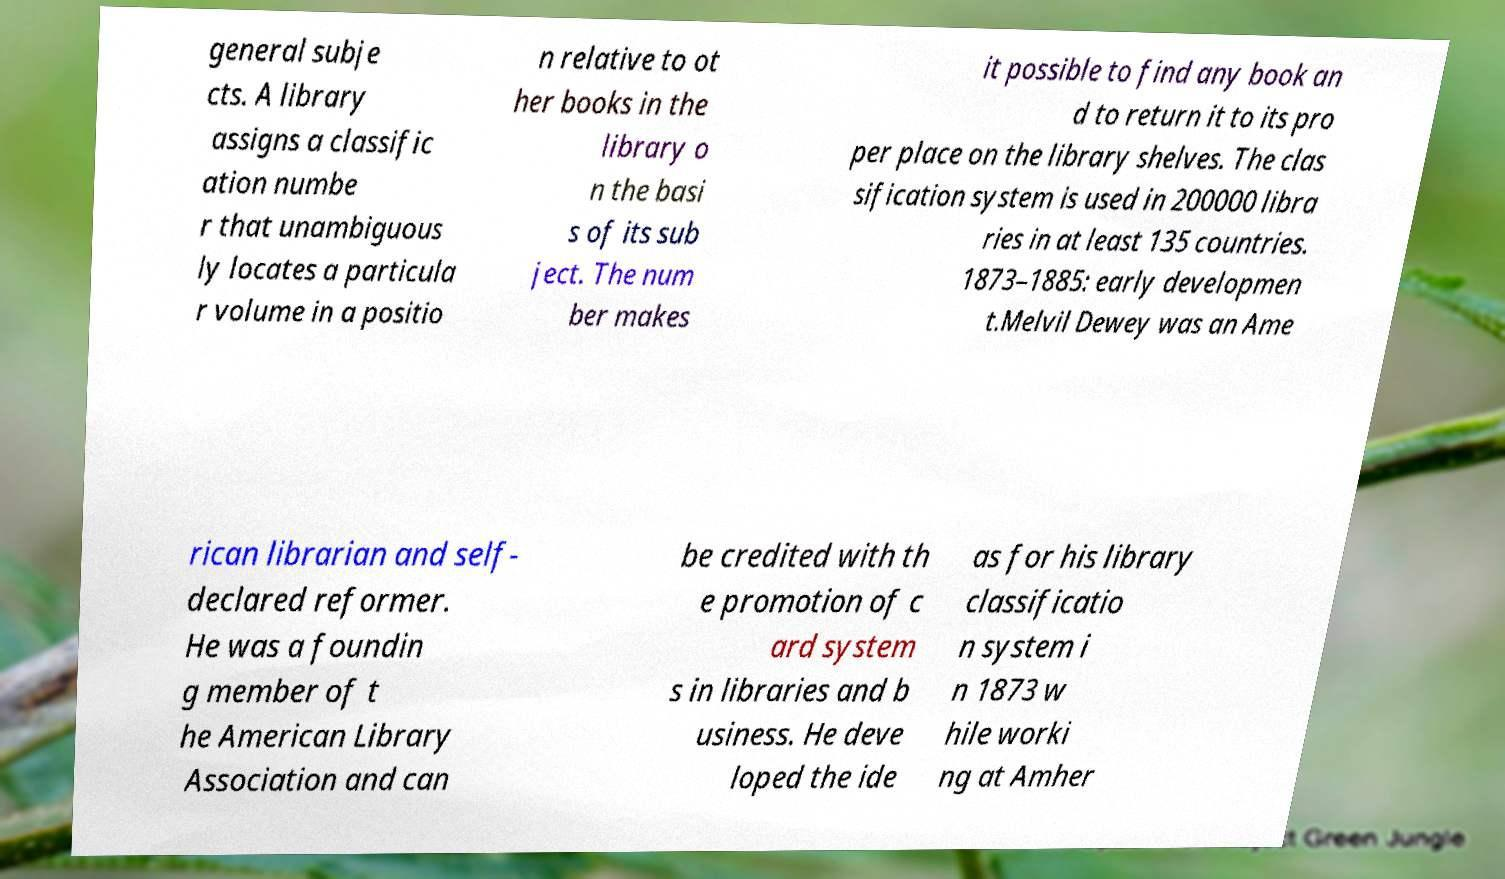For documentation purposes, I need the text within this image transcribed. Could you provide that? general subje cts. A library assigns a classific ation numbe r that unambiguous ly locates a particula r volume in a positio n relative to ot her books in the library o n the basi s of its sub ject. The num ber makes it possible to find any book an d to return it to its pro per place on the library shelves. The clas sification system is used in 200000 libra ries in at least 135 countries. 1873–1885: early developmen t.Melvil Dewey was an Ame rican librarian and self- declared reformer. He was a foundin g member of t he American Library Association and can be credited with th e promotion of c ard system s in libraries and b usiness. He deve loped the ide as for his library classificatio n system i n 1873 w hile worki ng at Amher 